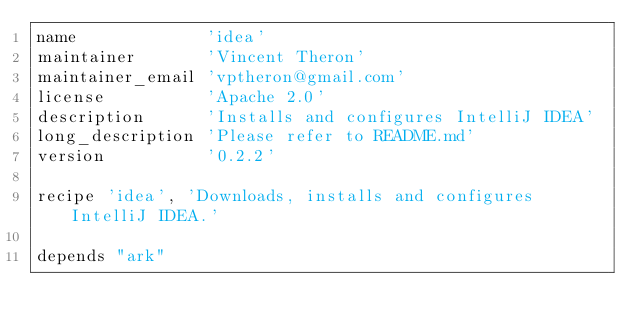Convert code to text. <code><loc_0><loc_0><loc_500><loc_500><_Ruby_>name             'idea'
maintainer       'Vincent Theron'
maintainer_email 'vptheron@gmail.com'
license          'Apache 2.0'
description      'Installs and configures IntelliJ IDEA'
long_description 'Please refer to README.md'
version          '0.2.2'

recipe 'idea', 'Downloads, installs and configures IntelliJ IDEA.'

depends "ark"
</code> 